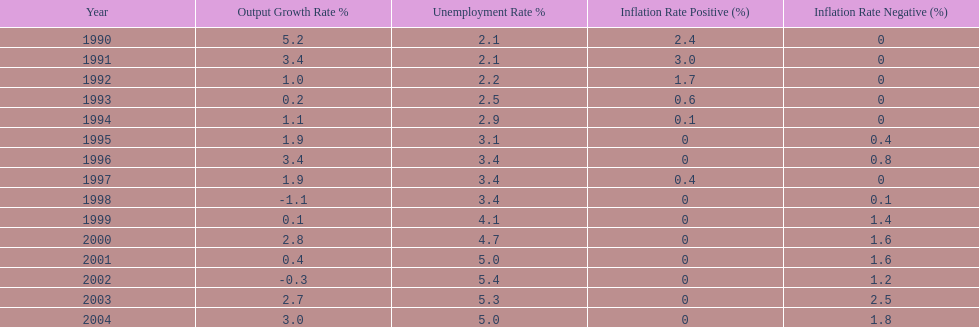What year had the highest unemployment rate? 2002. 